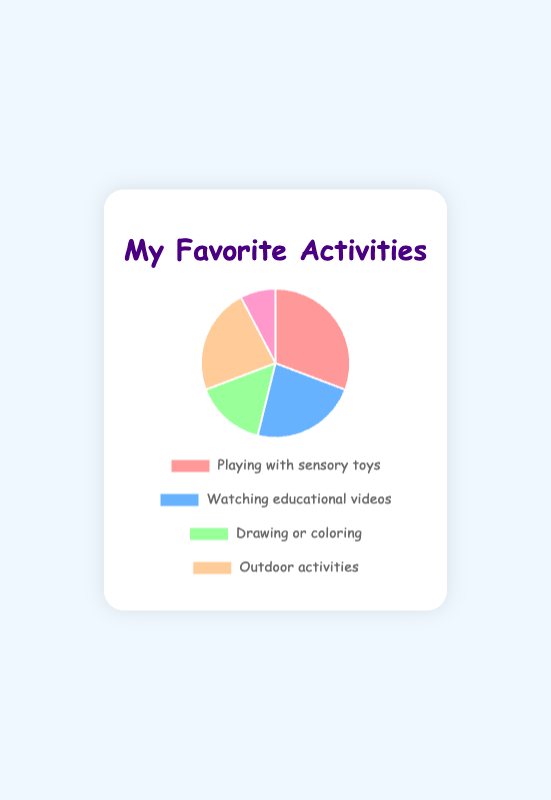Which activity takes up the most time? The slice labeled "Playing with sensory toys" is the largest and corresponds to 120 minutes.
Answer: Playing with sensory toys Which activity takes up the least time? The smallest slice in the pie chart is "Reading picture books," which is 30 minutes.
Answer: Reading picture books Which activities take the same amount of time? The slices for "Watching educational videos" and "Outdoor activities (e.g., swinging, slides)" are both of medium size, each corresponding to 90 minutes.
Answer: Watching educational videos and Outdoor activities (e.g., swinging, slides) How much more time is spent playing with sensory toys compared to reading picture books? "Playing with sensory toys" equals 120 minutes, and "Reading picture books" equals 30 minutes. Subtracting 30 from 120 gives 90 minutes more.
Answer: 90 minutes How much combined time is spent on activities involving screens? (Watching educational videos) The only screen-related activity is "Watching educational videos," which equals 90 minutes.
Answer: 90 minutes What is the average time spent on the activities? Sum all the times (120 + 90 + 60 + 90 + 30 = 390) and divide by the number of activities (5). Therefore, the average time is 390 / 5 = 78 minutes.
Answer: 78 minutes Is more time spent on outdoor activities or playing with sensory toys? "Playing with sensory toys" equals 120 minutes, while "Outdoor activities" equals 90 minutes. 120 minutes is greater than 90 minutes.
Answer: Playing with sensory toys Which activity takes up a quarter of the total time? The total time equals 390 minutes. One-quarter equals 390 / 4 = 97.5 minutes. The slice closest to this value is "Watching educational videos," corresponding to 90 minutes.
Answer: Watching educational videos What percentage of the total time is spent drawing or coloring? Drawing or coloring takes 60 minutes. The total time is 390 minutes. (60 / 390) * 100 ≈ 15.38%.
Answer: Approximately 15.38% How many more minutes are spent playing with sensory toys than drawing or coloring? "Playing with sensory toys" equals 120 minutes; "Drawing or coloring" equals 60 minutes. Subtracting 60 from 120 gives 60 minutes more.
Answer: 60 minutes 